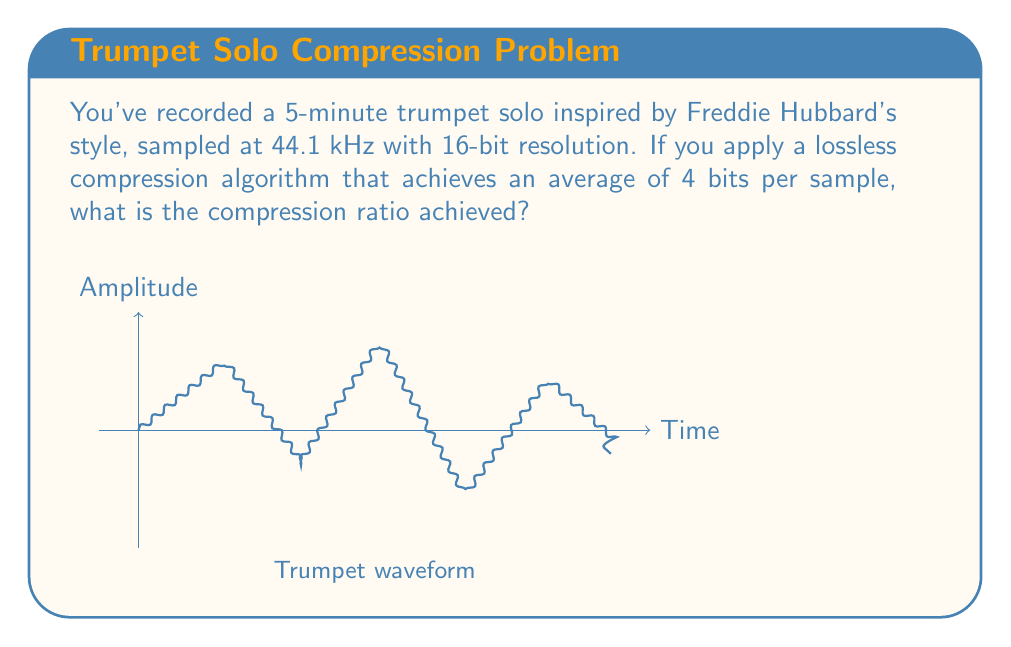Could you help me with this problem? Let's approach this step-by-step:

1) First, calculate the original file size:
   - Duration: 5 minutes = 300 seconds
   - Sampling rate: 44.1 kHz = 44,100 samples/second
   - Bit depth: 16 bits/sample
   
   Original file size = $300 \text{ s} \times 44,100 \text{ samples/s} \times 16 \text{ bits/sample}$
                      = $211,680,000 \text{ bits}$

2) Now, calculate the compressed file size:
   - Compressed data uses 4 bits/sample
   
   Compressed file size = $300 \text{ s} \times 44,100 \text{ samples/s} \times 4 \text{ bits/sample}$
                        = $52,920,000 \text{ bits}$

3) The compression ratio is defined as:
   $$ \text{Compression Ratio} = \frac{\text{Original Size}}{\text{Compressed Size}} $$

4) Substituting our values:
   $$ \text{Compression Ratio} = \frac{211,680,000}{52,920,000} = 4 $$

Therefore, the compression ratio achieved is 4:1.
Answer: 4:1 